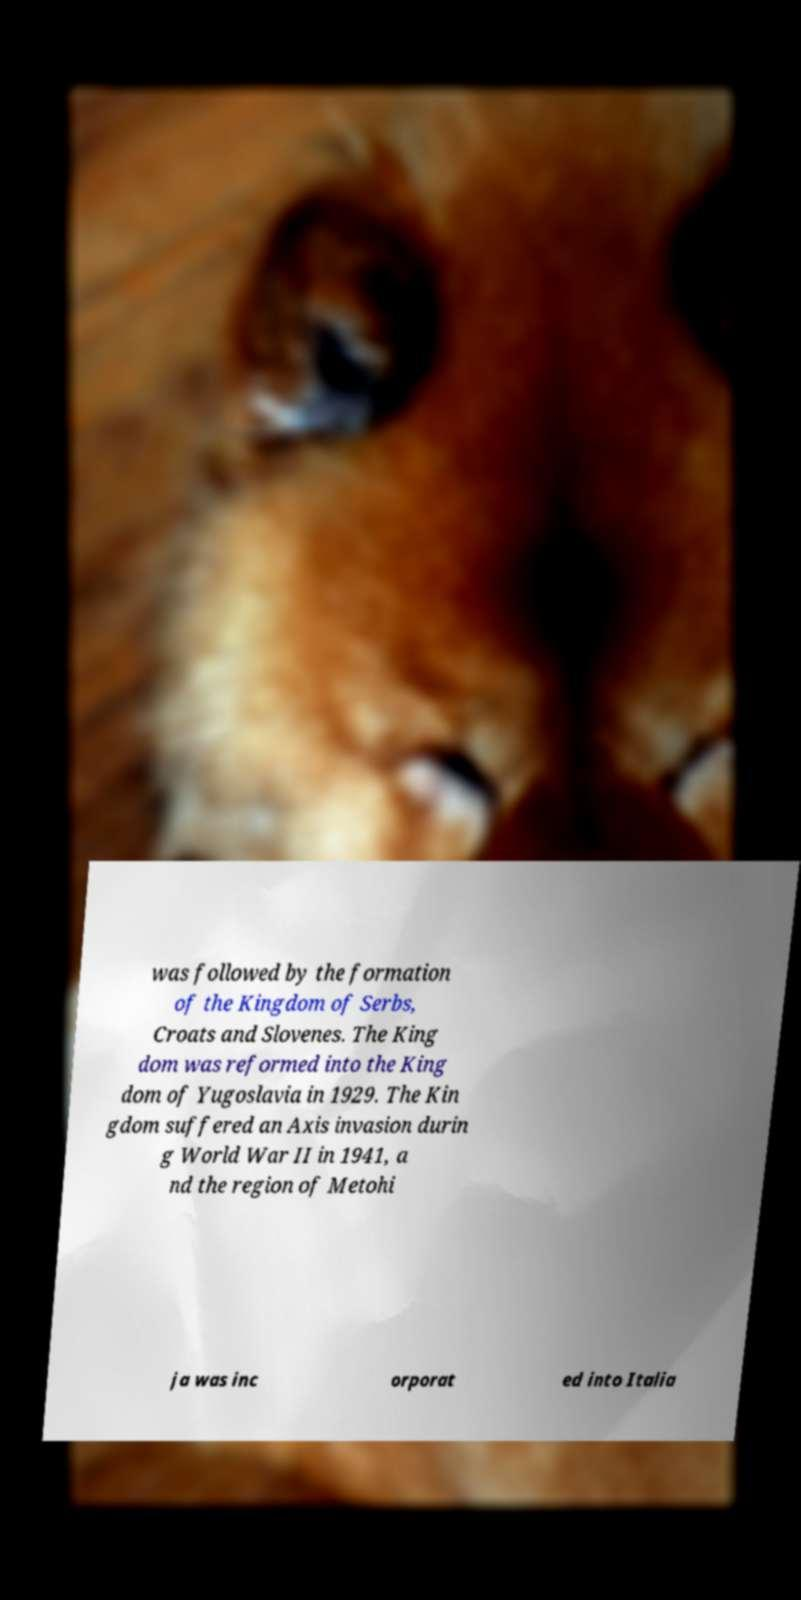Could you extract and type out the text from this image? was followed by the formation of the Kingdom of Serbs, Croats and Slovenes. The King dom was reformed into the King dom of Yugoslavia in 1929. The Kin gdom suffered an Axis invasion durin g World War II in 1941, a nd the region of Metohi ja was inc orporat ed into Italia 